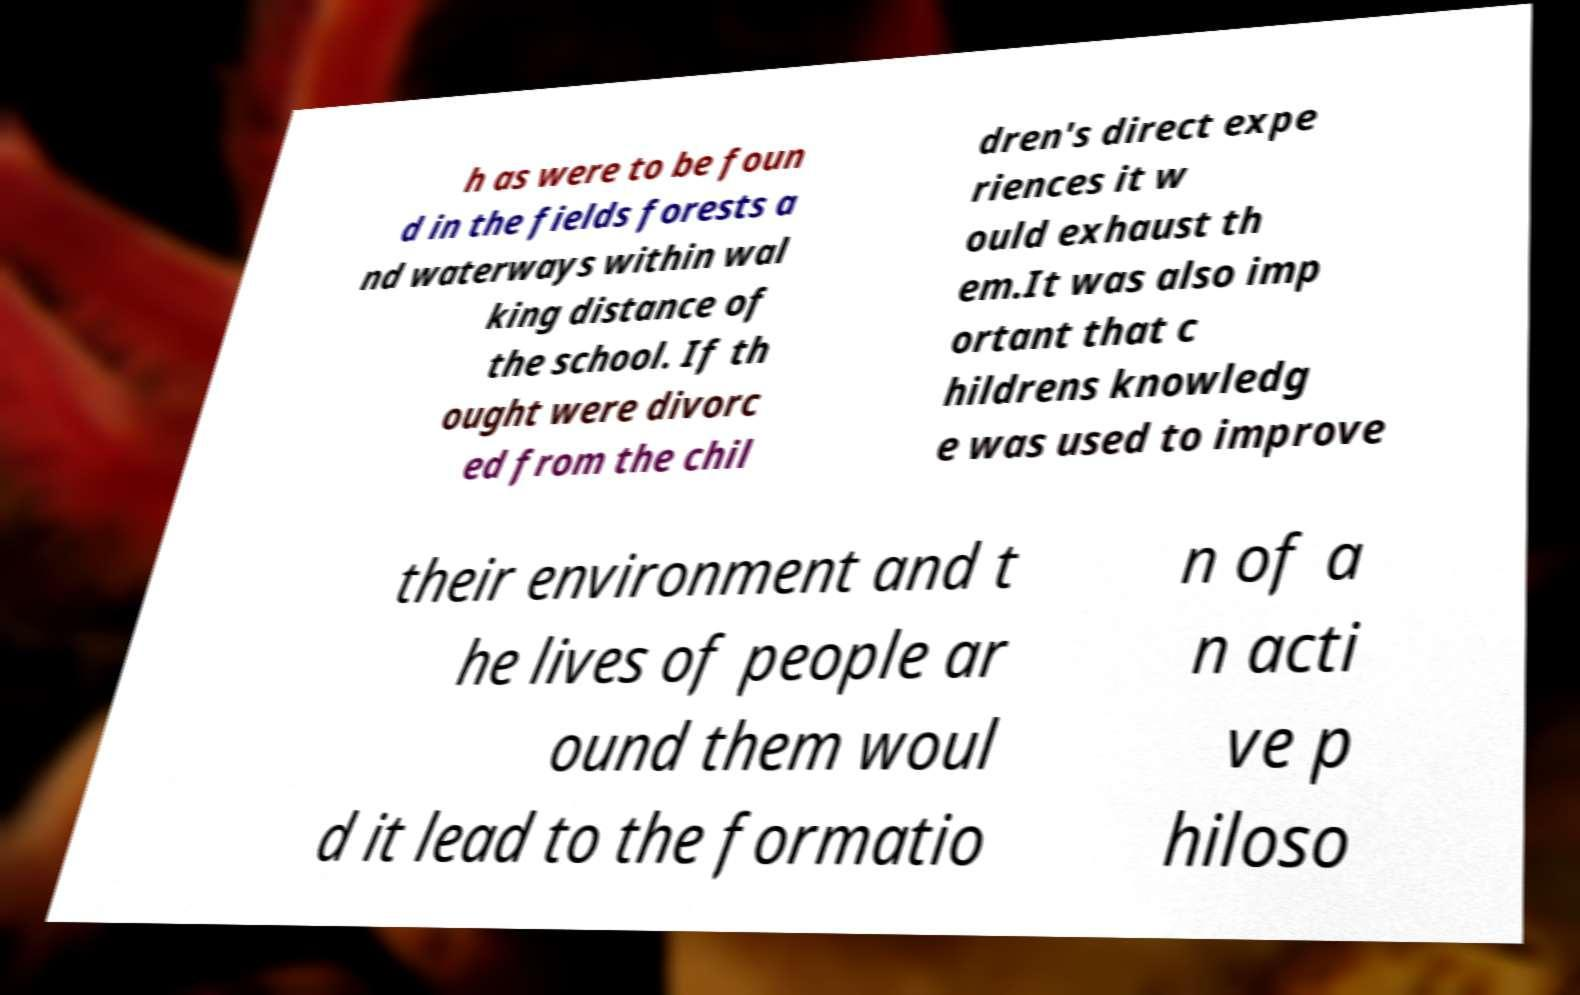There's text embedded in this image that I need extracted. Can you transcribe it verbatim? h as were to be foun d in the fields forests a nd waterways within wal king distance of the school. If th ought were divorc ed from the chil dren's direct expe riences it w ould exhaust th em.It was also imp ortant that c hildrens knowledg e was used to improve their environment and t he lives of people ar ound them woul d it lead to the formatio n of a n acti ve p hiloso 